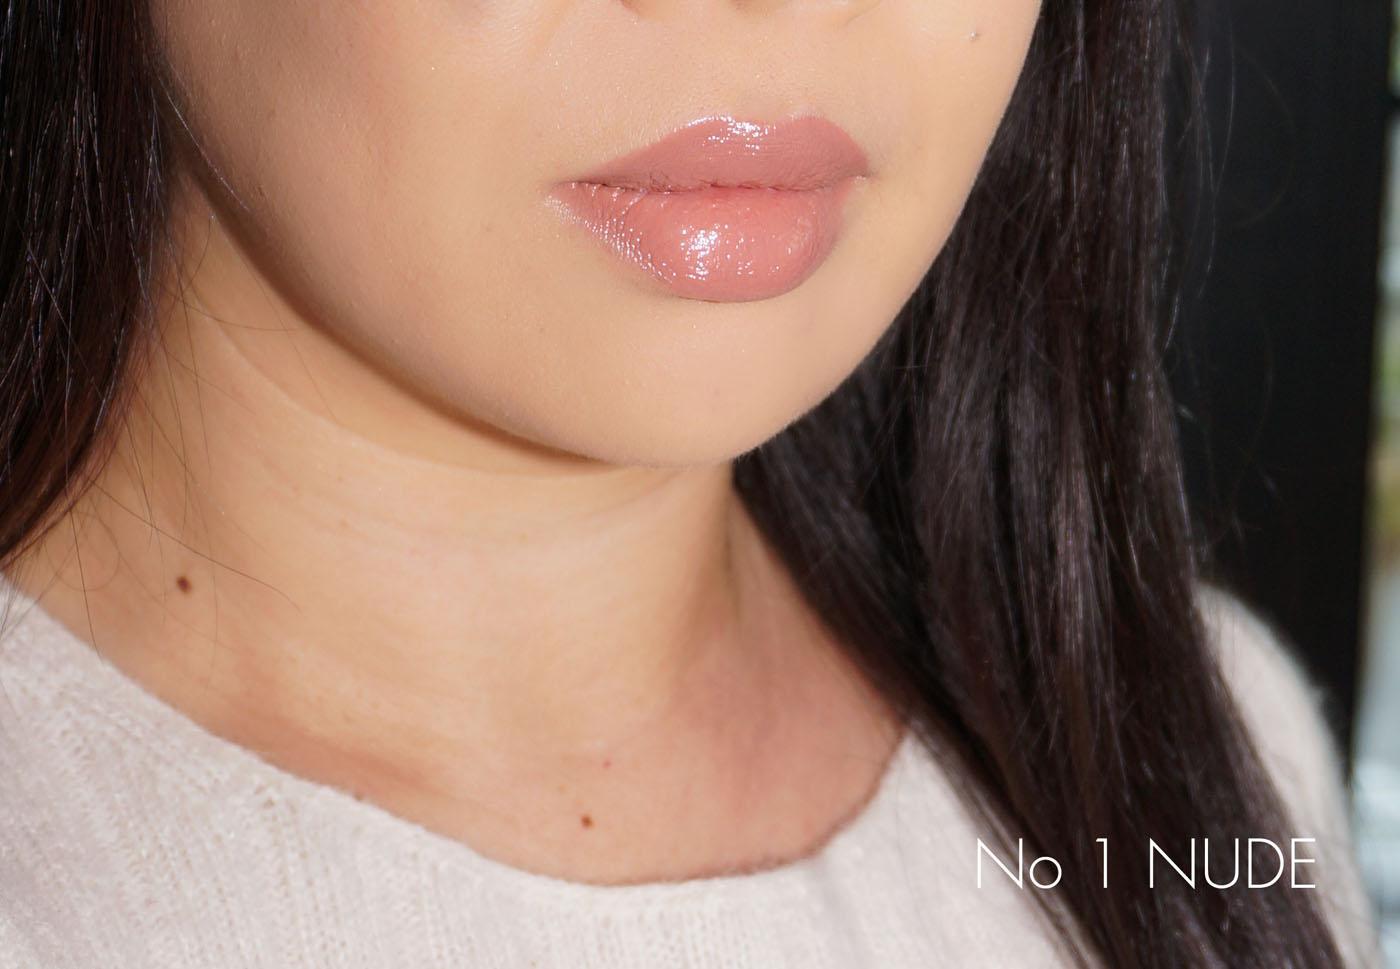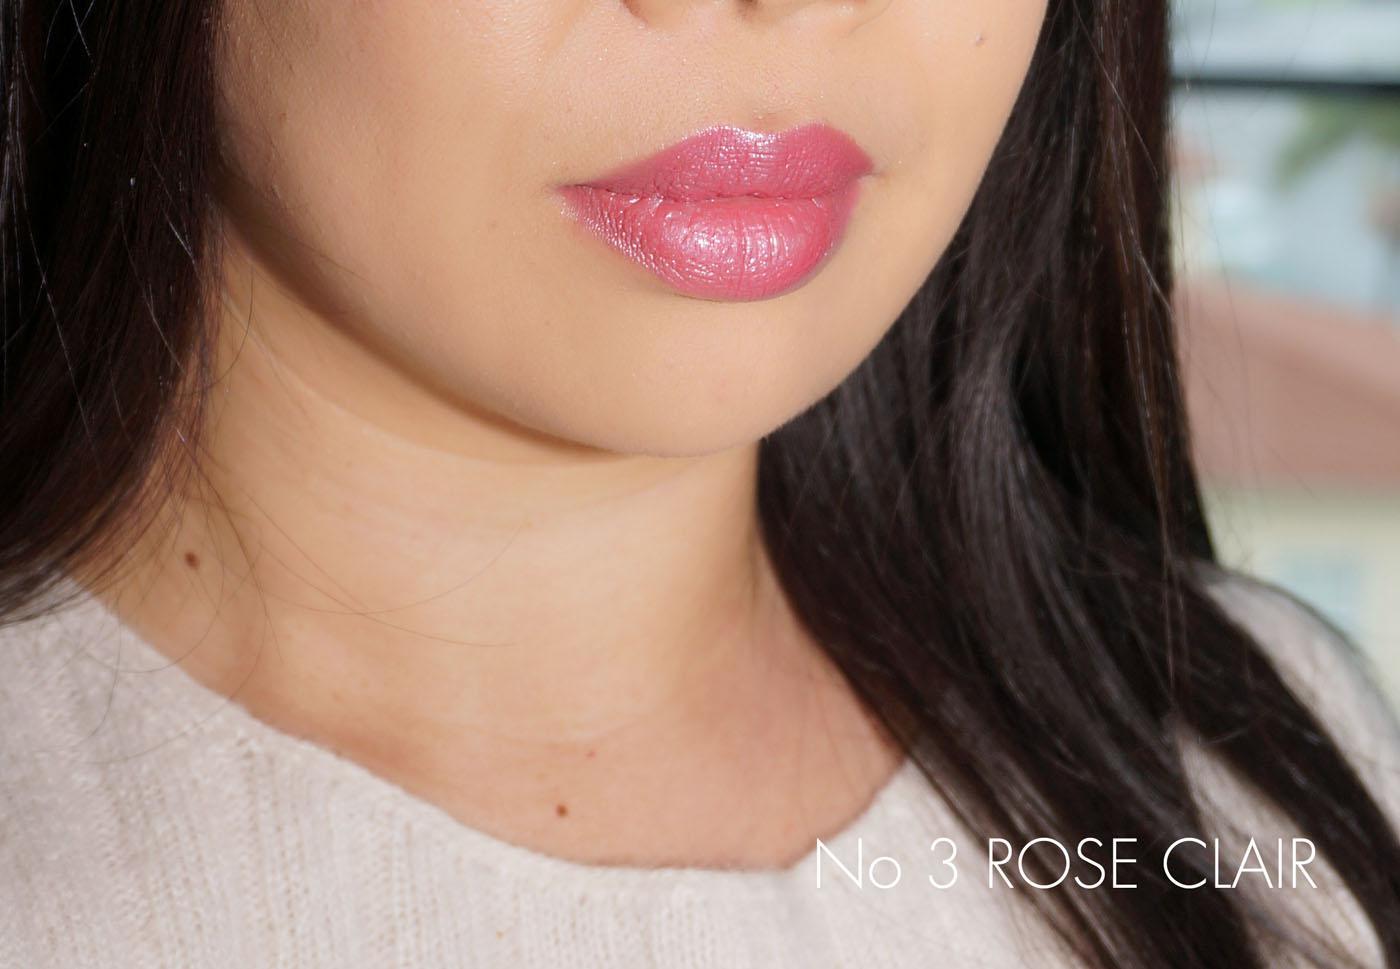The first image is the image on the left, the second image is the image on the right. Examine the images to the left and right. Is the description "Both images show a brunette model with tinted, closed lips, and both models wear a pale top with a round neckline." accurate? Answer yes or no. Yes. The first image is the image on the left, the second image is the image on the right. For the images displayed, is the sentence "There are two girls wearing pale pink lipstick." factually correct? Answer yes or no. Yes. 